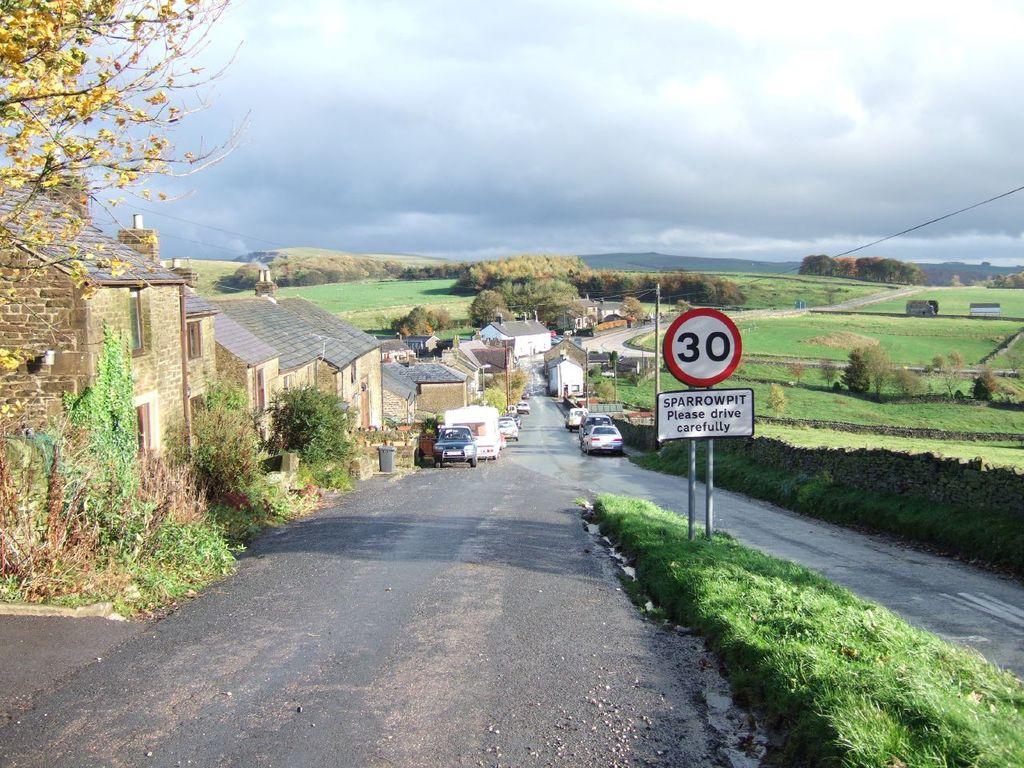What is the number listed on the sign?
Offer a very short reply. 30. 